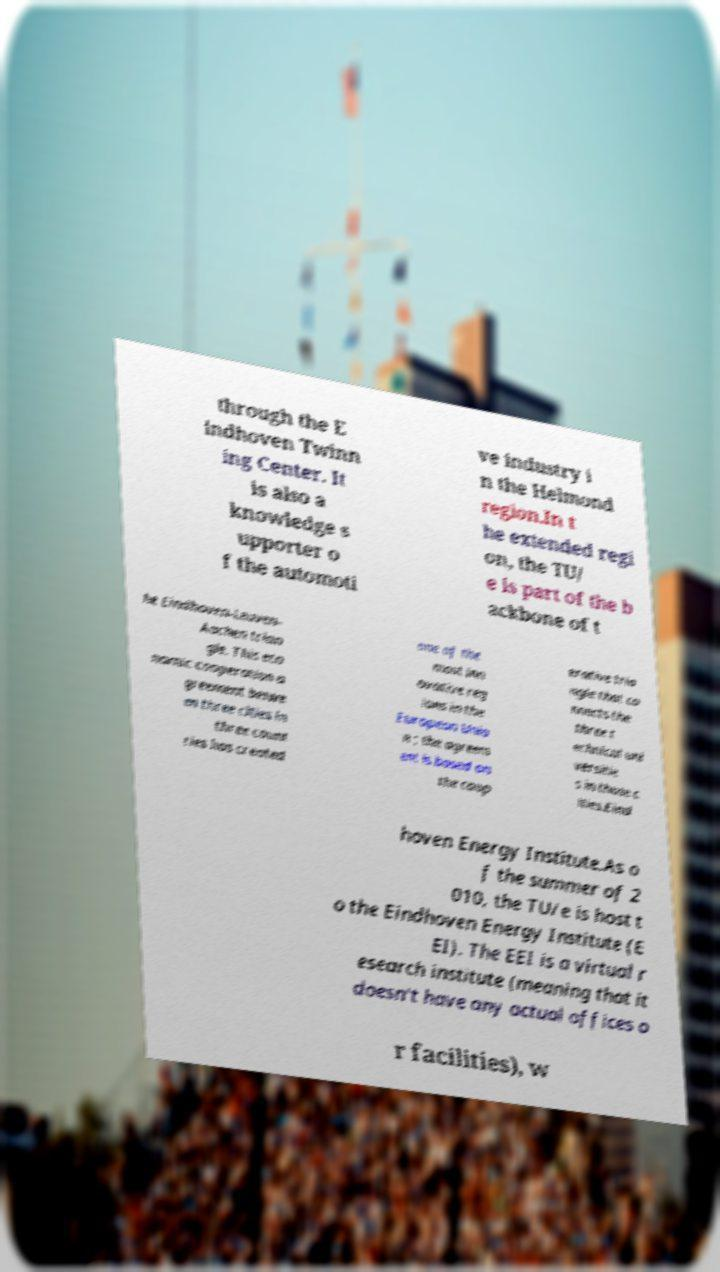There's text embedded in this image that I need extracted. Can you transcribe it verbatim? through the E indhoven Twinn ing Center. It is also a knowledge s upporter o f the automoti ve industry i n the Helmond region.In t he extended regi on, the TU/ e is part of the b ackbone of t he Eindhoven-Leuven- Aachen trian gle. This eco nomic cooperation a greement betwe en three cities in three count ries has created one of the most inn ovative reg ions in the European Unio n ; the agreem ent is based on the coop erative tria ngle that co nnects the three t echnical uni versitie s in those c ities.Eind hoven Energy Institute.As o f the summer of 2 010, the TU/e is host t o the Eindhoven Energy Institute (E EI). The EEI is a virtual r esearch institute (meaning that it doesn't have any actual offices o r facilities), w 